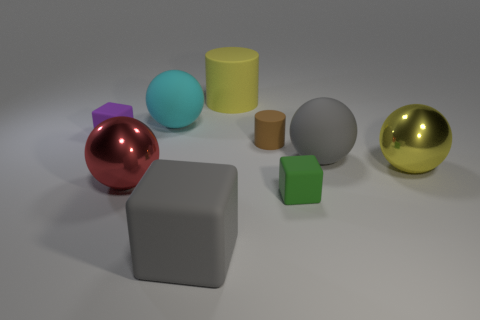What is the color of the other small object that is the same shape as the green object?
Offer a very short reply. Purple. What is the shape of the metallic thing left of the small block in front of the large shiny ball to the left of the big cyan object?
Provide a succinct answer. Sphere. Is the large cyan rubber thing the same shape as the green thing?
Your answer should be compact. No. What shape is the big thing left of the big matte sphere that is left of the large matte cylinder?
Give a very brief answer. Sphere. Are there any yellow rubber cylinders?
Make the answer very short. Yes. There is a thing that is left of the big metallic sphere that is to the left of the tiny brown rubber cylinder; how many big cyan matte things are to the left of it?
Keep it short and to the point. 0. There is a brown matte object; is it the same shape as the large object that is in front of the big red metallic thing?
Offer a terse response. No. Is the number of yellow blocks greater than the number of big balls?
Offer a terse response. No. There is a tiny object that is left of the cyan thing; is its shape the same as the tiny green thing?
Offer a terse response. Yes. Is the number of small rubber blocks that are behind the large gray matte cube greater than the number of cyan objects?
Offer a terse response. Yes. 